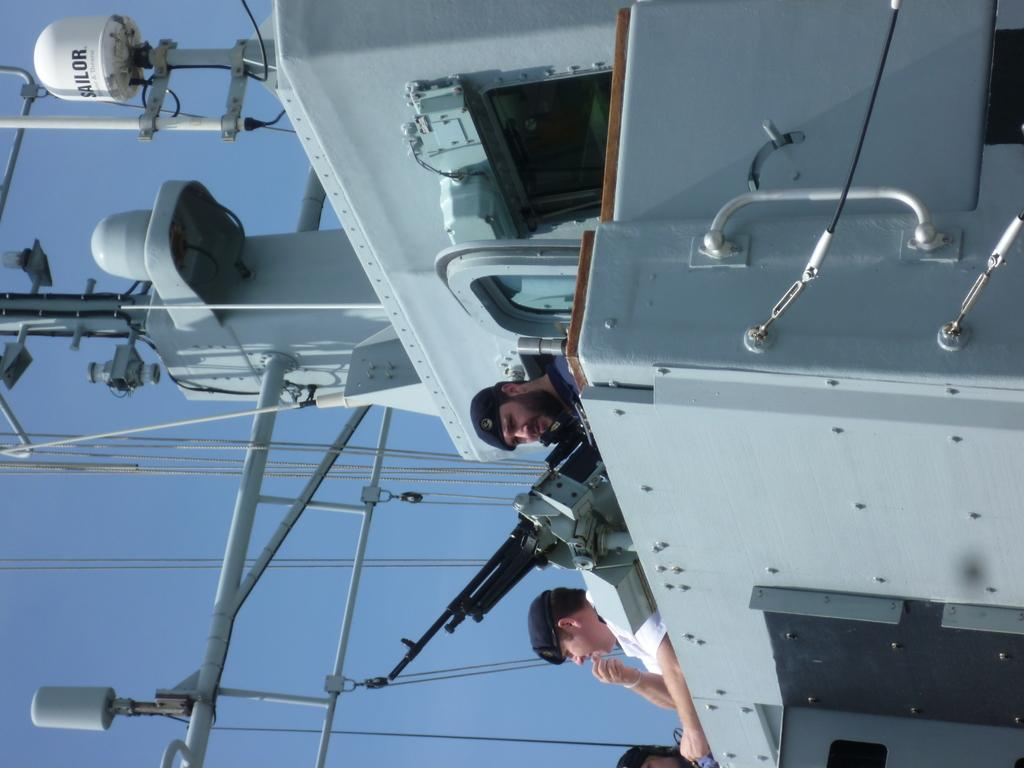What is the main subject of the image? The main subject of the image is a ship. How many people are in the image? There are three persons in the image. What object can be seen in the image that is typically used for self-defense or hunting? There is a gun in the image. What can be seen on the left side of the image? There are wires on the left side of the image. What is visible in the background of the image? The sky is visible in the background of the image. How many hens are visible in the image? There are no hens present in the image. What type of basin is being used by the beginner in the image? There is no beginner or basin present in the image. 